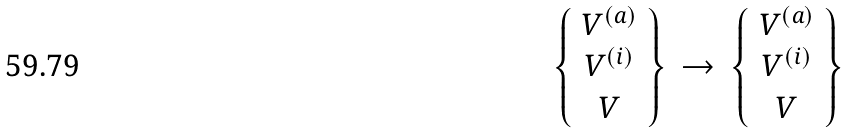Convert formula to latex. <formula><loc_0><loc_0><loc_500><loc_500>\left \{ \begin{array} { c } V ^ { ( a ) } \\ V ^ { ( i ) } \\ V \end{array} \right \} \, \rightarrow \, \left \{ \begin{array} { c } V ^ { ( a ) } \\ V ^ { ( i ) } \\ V \end{array} \right \}</formula> 